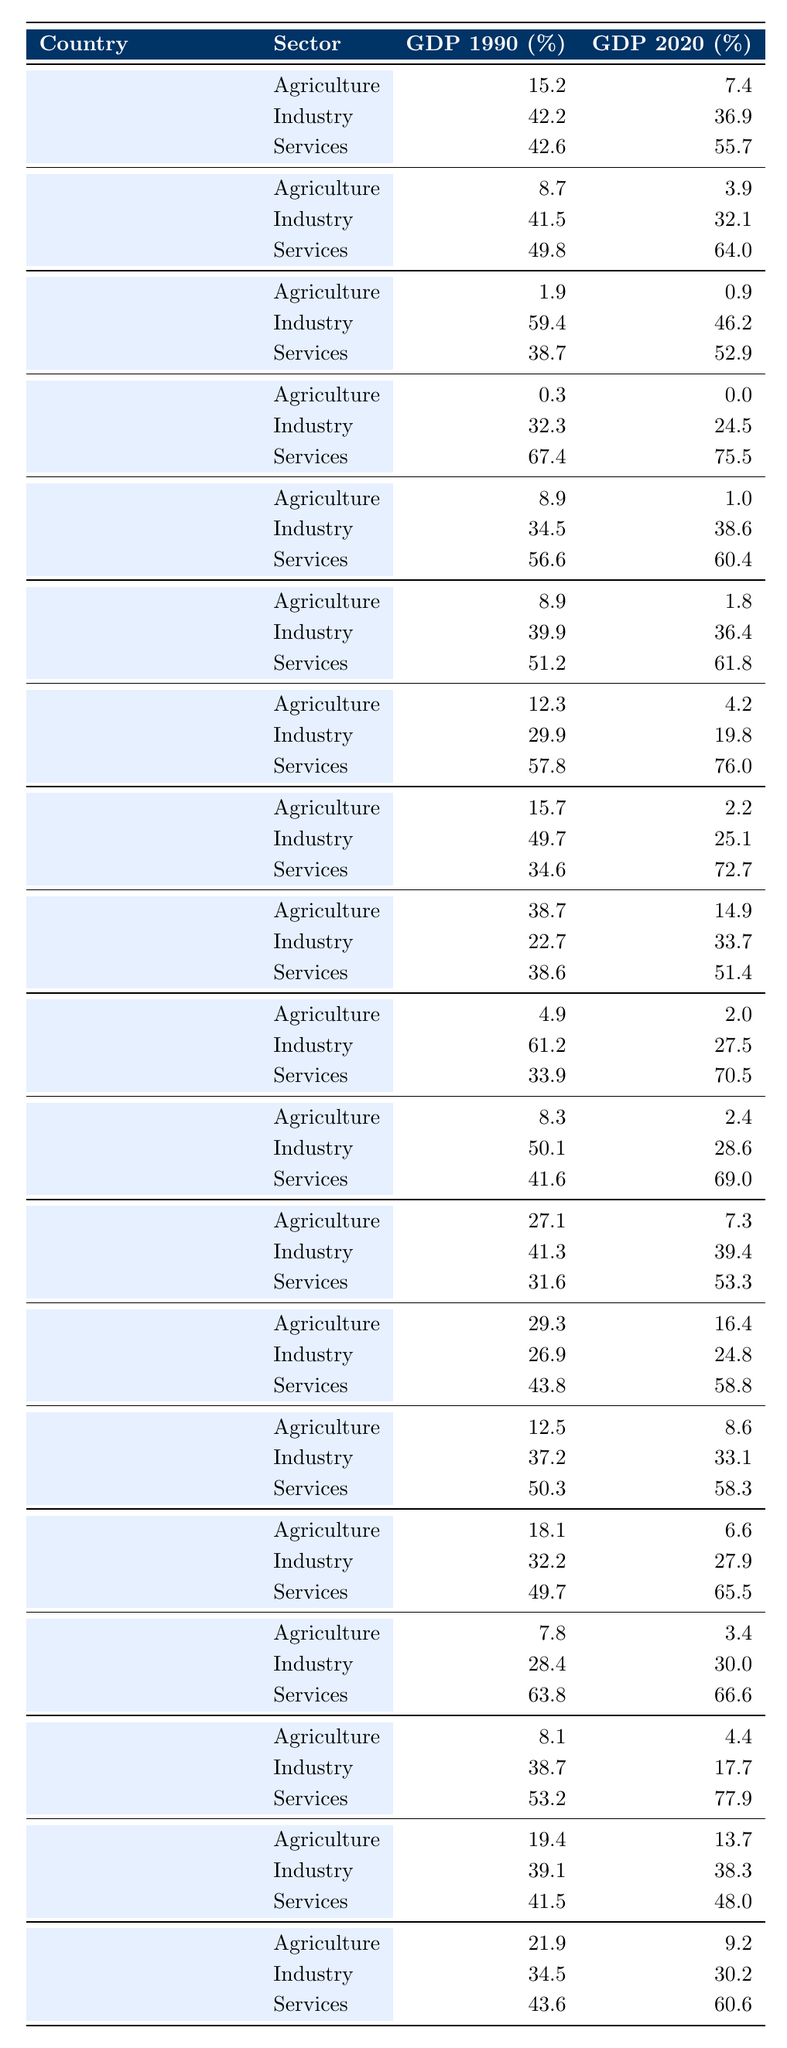What was the GDP contribution of the services sector for Malaysia in 1990? According to the table, the GDP contribution of the services sector for Malaysia in 1990 is listed as 42.6%.
Answer: 42.6% Which country had the highest contribution from the services sector in 2020? By examining the table, in 2020, Brazil had the highest contribution from the services sector at 77.9%.
Answer: Brazil What was the change in GDP contribution from the agricultural sector in Chile from 1990 to 2020? Chile's agricultural sector contributed 8.7% in 1990 and decreased to 3.9% in 2020. The change is 3.9% - 8.7% = -4.8%.
Answer: -4.8% How much did the industrial sector's GDP contribution decrease in Botswana from 1990 to 2020? In Botswana, the industrial sector's contribution was 61.2% in 1990 and dropped to 27.5% in 2020. The decrease is 61.2% - 27.5% = 33.7%.
Answer: 33.7% Is the contribution of the services sector in the United Arab Emirates greater in 2020 than in 1990? In the United Arab Emirates, the services sector contributed 38.7% in 1990 and 52.9% in 2020, indicating an increase.
Answer: Yes Which country saw the largest increase in services sector contribution from 1990 to 2020? By reviewing the table, Costa Rica had a contribution of 57.8% in 1990 and increased to 76.0% in 2020. The increase of 18.2% indicates it had the largest growth in services.
Answer: Costa Rica What was the average GDP contribution of the industrial sector for all countries in 1990? To find the average, sum the contributions of the industrial sector: (42.2 + 41.5 + 59.4 + 32.3 + 34.5 + 39.9 + 29.9 + 49.7 + 22.7 + 61.2 + 50.1 + 41.3 + 26.9 + 37.2 + 32.2 + 28.4 + 38.7 + 39.1 + 34.5) = 695.5%. There are 20 contributions, so the average is 695.5% / 20 = 34.775%.
Answer: 34.775% How much did the contribution from the agricultural sector decline in Vietnam from 1990 to 2020? The agricultural sector contribution in Vietnam went from 38.7% in 1990 to 14.9% in 2020, indicating a decline of 38.7% - 14.9% = 23.8%.
Answer: 23.8% In 2020, did any country have a GDP contribution from the industry sector below 30%? Checking the table, Singapore had an industrial sector contribution of 24.5%, which is below 30%.
Answer: Yes What is the total GDP contribution from the services sector for all countries in 2020? The total contribution for 2020 is derived by summing all values in the services sector: (55.7 + 64.0 + 52.9 + 75.5 + 60.4 + 61.8 + 76.0 + 72.7 + 51.4 + 70.5 + 69.0 + 53.3 + 58.8 + 58.3 + 65.5 + 66.6 + 77.9 + 48.0 + 60.6) = 1009.2%.
Answer: 1009.2% 